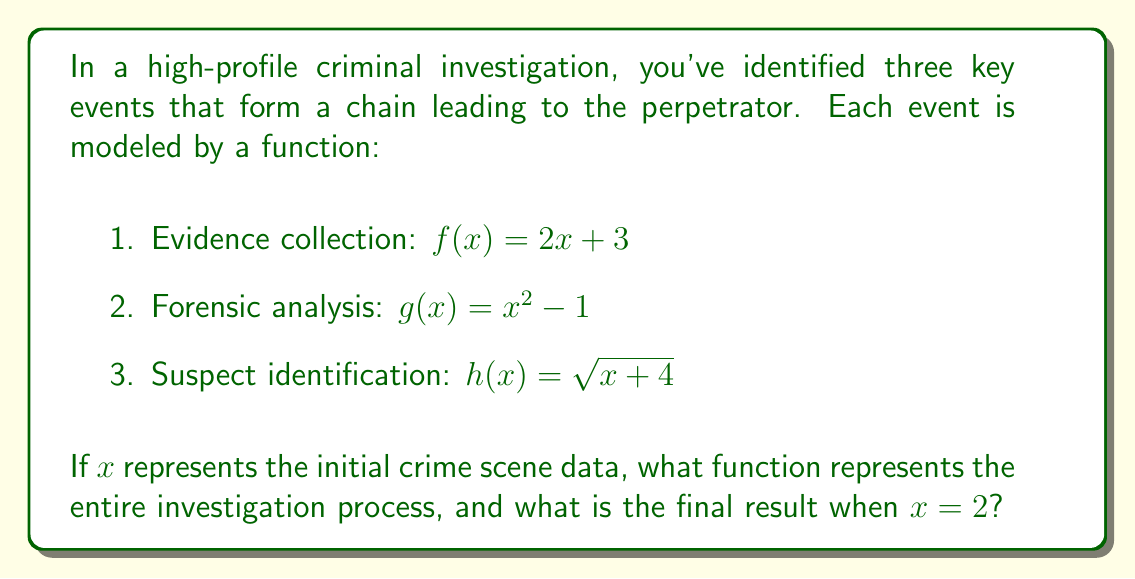Can you solve this math problem? To model the entire investigation process, we need to compose the functions in the order they occur:

1. First, we apply $f(x)$ to the initial crime scene data.
2. Then, we apply $g(x)$ to the result of $f(x)$.
3. Finally, we apply $h(x)$ to the result of $g(f(x))$.

Let's compose these functions step by step:

1. $g(f(x)) = g(2x + 3) = (2x + 3)^2 - 1 = 4x^2 + 12x + 9 - 1 = 4x^2 + 12x + 8$

2. Now, we compose $h(x)$ with the result of $g(f(x))$:
   $h(g(f(x))) = \sqrt{(4x^2 + 12x + 8) + 4} = \sqrt{4x^2 + 12x + 12}$

This function $h(g(f(x))) = \sqrt{4x^2 + 12x + 12}$ represents the entire investigation process.

To find the final result when $x = 2$, we substitute $x = 2$ into this function:

$\sqrt{4(2)^2 + 12(2) + 12} = \sqrt{16 + 24 + 12} = \sqrt{52} = 2\sqrt{13}$
Answer: $h(g(f(x))) = \sqrt{4x^2 + 12x + 12}$; Final result when $x = 2$: $2\sqrt{13}$ 